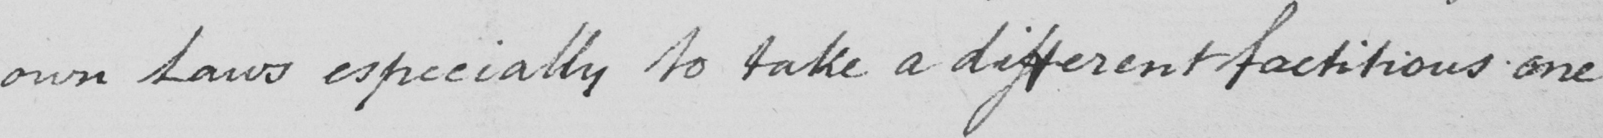Please provide the text content of this handwritten line. own Laws especially to take a different factitious one 